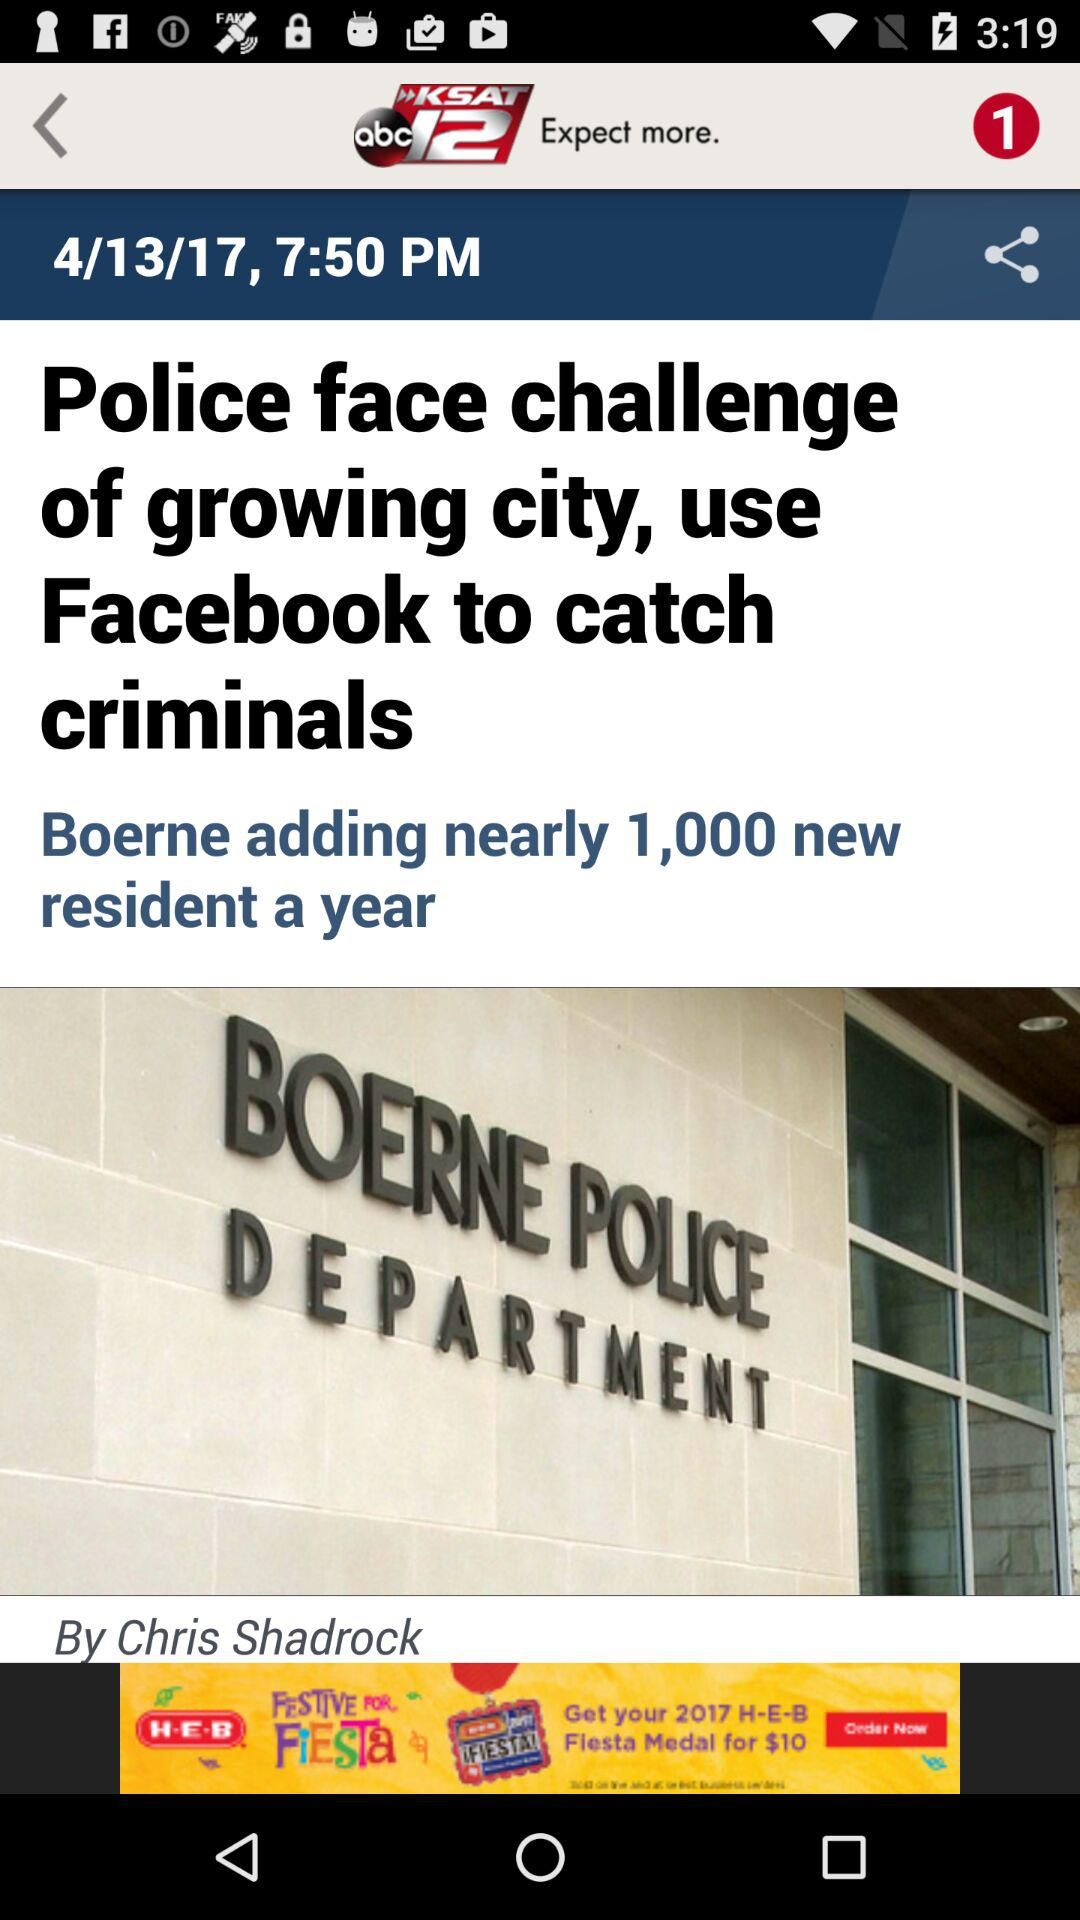What's the published time of the article? The published time is 7:50 PM. 